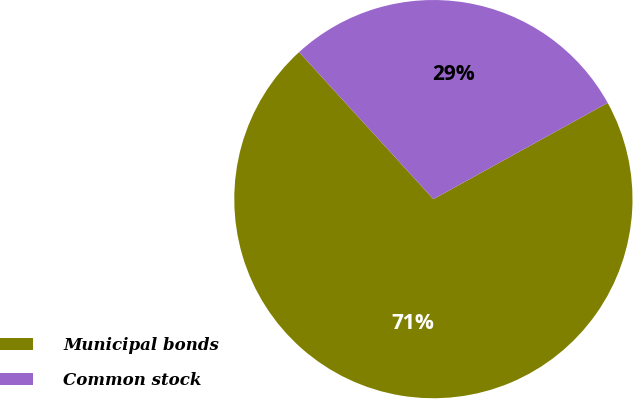<chart> <loc_0><loc_0><loc_500><loc_500><pie_chart><fcel>Municipal bonds<fcel>Common stock<nl><fcel>71.25%<fcel>28.75%<nl></chart> 